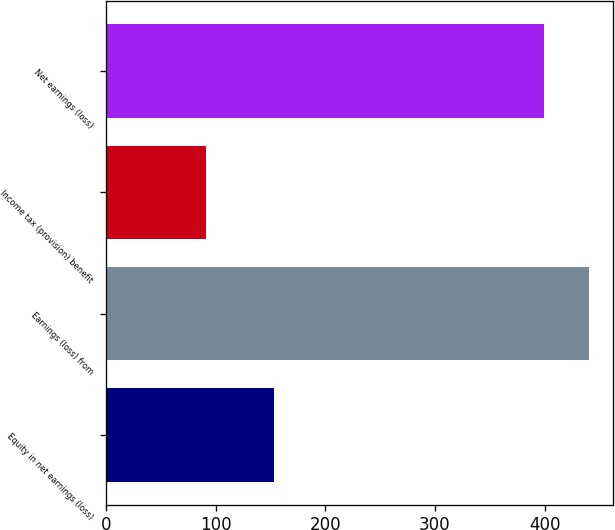Convert chart. <chart><loc_0><loc_0><loc_500><loc_500><bar_chart><fcel>Equity in net earnings (loss)<fcel>Earnings (loss) from<fcel>Income tax (provision) benefit<fcel>Net earnings (loss)<nl><fcel>153<fcel>440.4<fcel>91<fcel>399.7<nl></chart> 